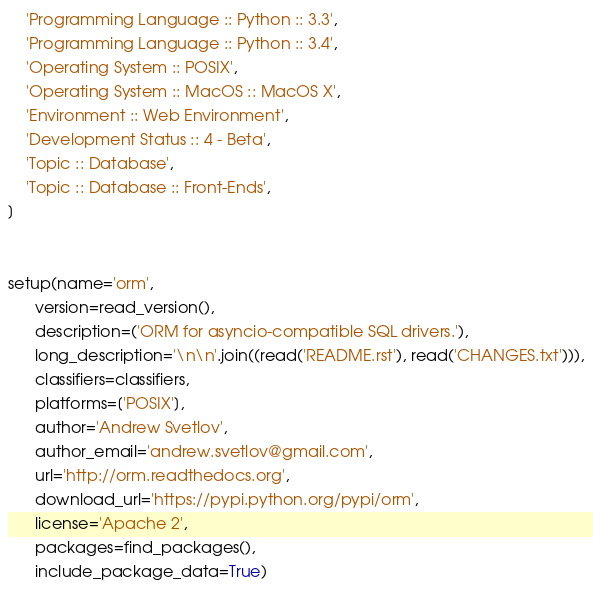Convert code to text. <code><loc_0><loc_0><loc_500><loc_500><_Python_>    'Programming Language :: Python :: 3.3',
    'Programming Language :: Python :: 3.4',
    'Operating System :: POSIX',
    'Operating System :: MacOS :: MacOS X',
    'Environment :: Web Environment',
    'Development Status :: 4 - Beta',
    'Topic :: Database',
    'Topic :: Database :: Front-Ends',
]


setup(name='orm',
      version=read_version(),
      description=('ORM for asyncio-compatible SQL drivers.'),
      long_description='\n\n'.join((read('README.rst'), read('CHANGES.txt'))),
      classifiers=classifiers,
      platforms=['POSIX'],
      author='Andrew Svetlov',
      author_email='andrew.svetlov@gmail.com',
      url='http://orm.readthedocs.org',
      download_url='https://pypi.python.org/pypi/orm',
      license='Apache 2',
      packages=find_packages(),
      include_package_data=True)
</code> 